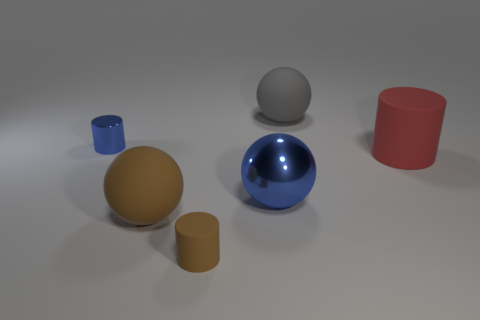Add 3 gray matte balls. How many objects exist? 9 Subtract all large brown spheres. How many spheres are left? 2 Subtract all cyan spheres. Subtract all green cylinders. How many spheres are left? 3 Add 2 red objects. How many red objects exist? 3 Subtract 0 blue blocks. How many objects are left? 6 Subtract all small shiny objects. Subtract all small blue things. How many objects are left? 4 Add 1 big red matte objects. How many big red matte objects are left? 2 